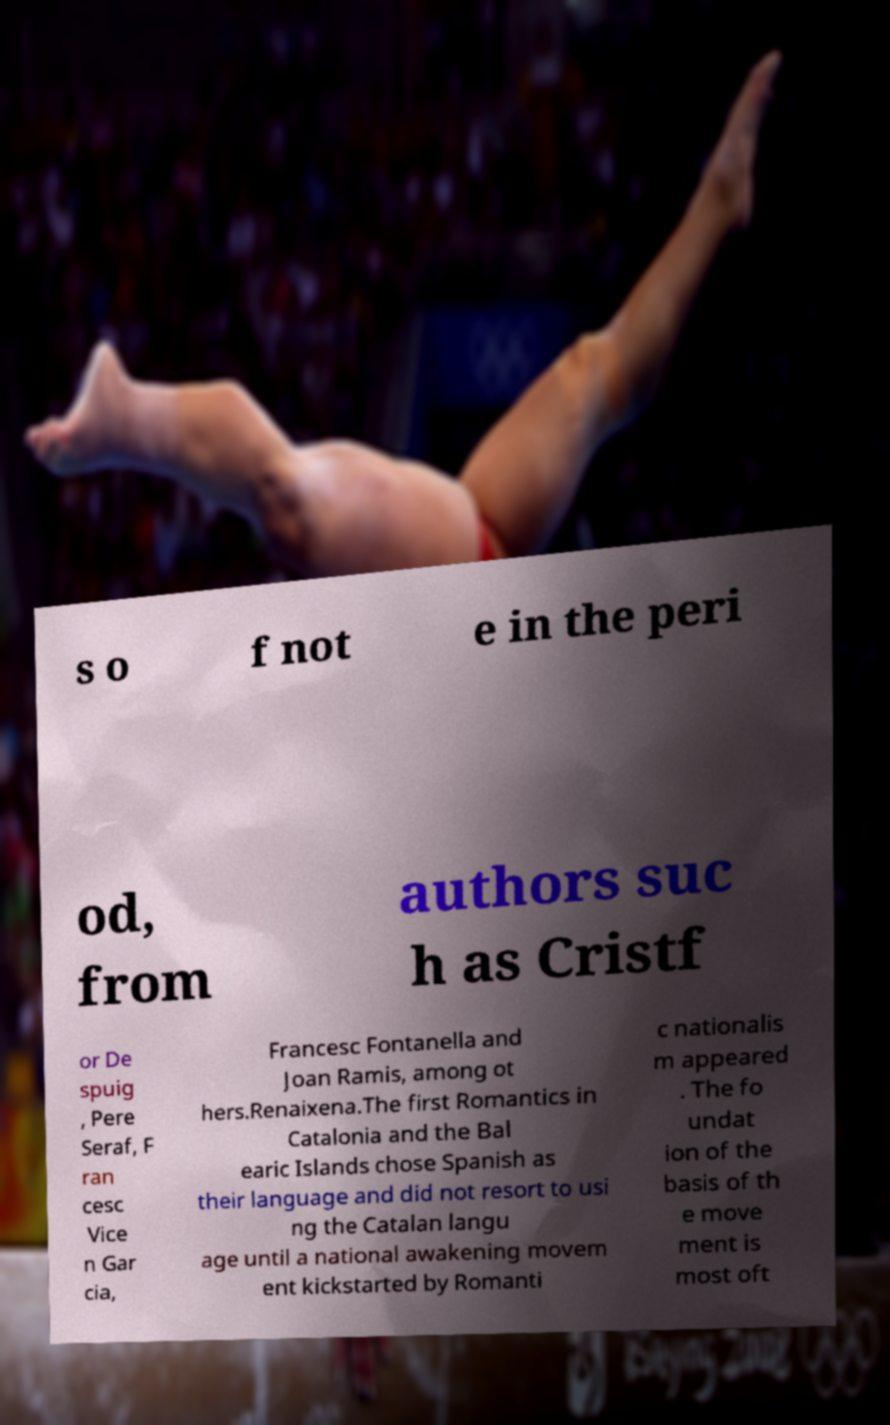I need the written content from this picture converted into text. Can you do that? s o f not e in the peri od, from authors suc h as Cristf or De spuig , Pere Seraf, F ran cesc Vice n Gar cia, Francesc Fontanella and Joan Ramis, among ot hers.Renaixena.The first Romantics in Catalonia and the Bal earic Islands chose Spanish as their language and did not resort to usi ng the Catalan langu age until a national awakening movem ent kickstarted by Romanti c nationalis m appeared . The fo undat ion of the basis of th e move ment is most oft 